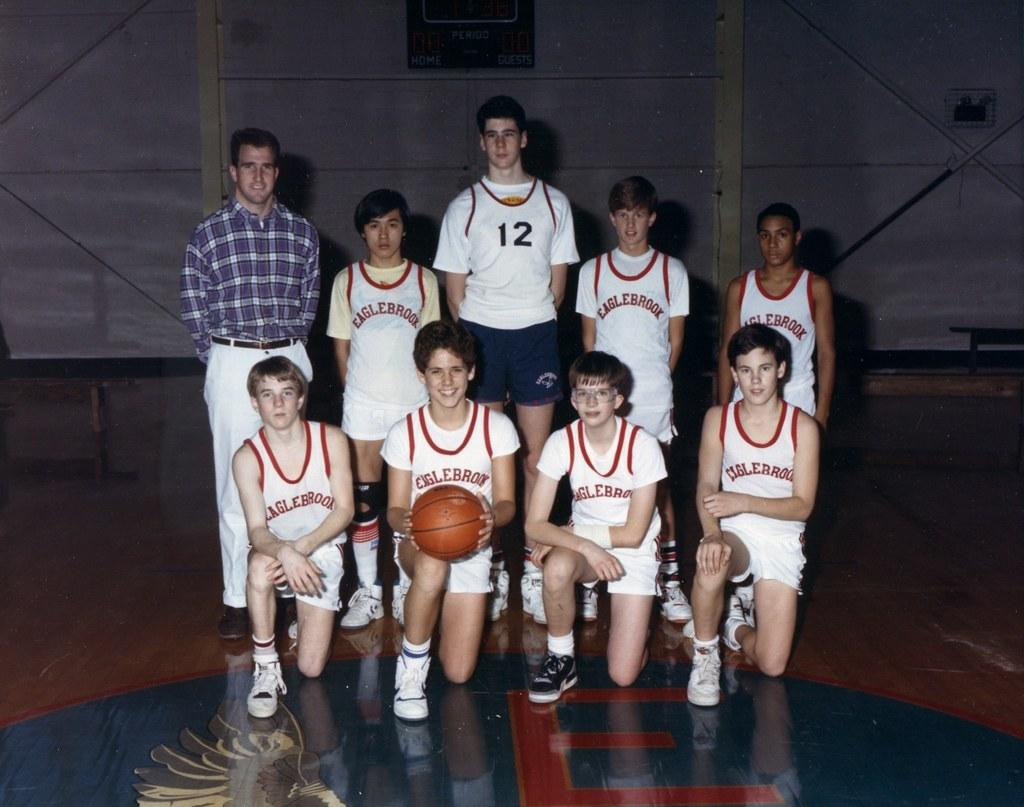Provide a one-sentence caption for the provided image. A group of basketball players with the back middle one with a 12 on front. 